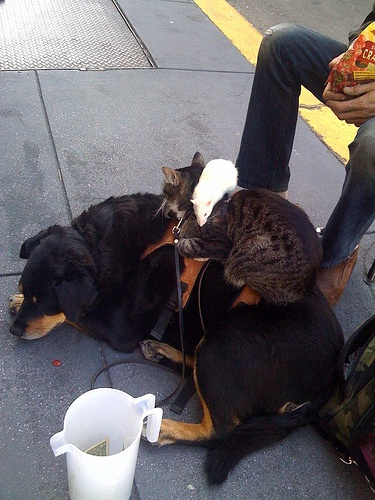Describe the objects in this image and their specific colors. I can see dog in gray, black, maroon, and brown tones, people in gray, black, and maroon tones, cat in gray, black, and white tones, and backpack in gray, black, and darkgreen tones in this image. 